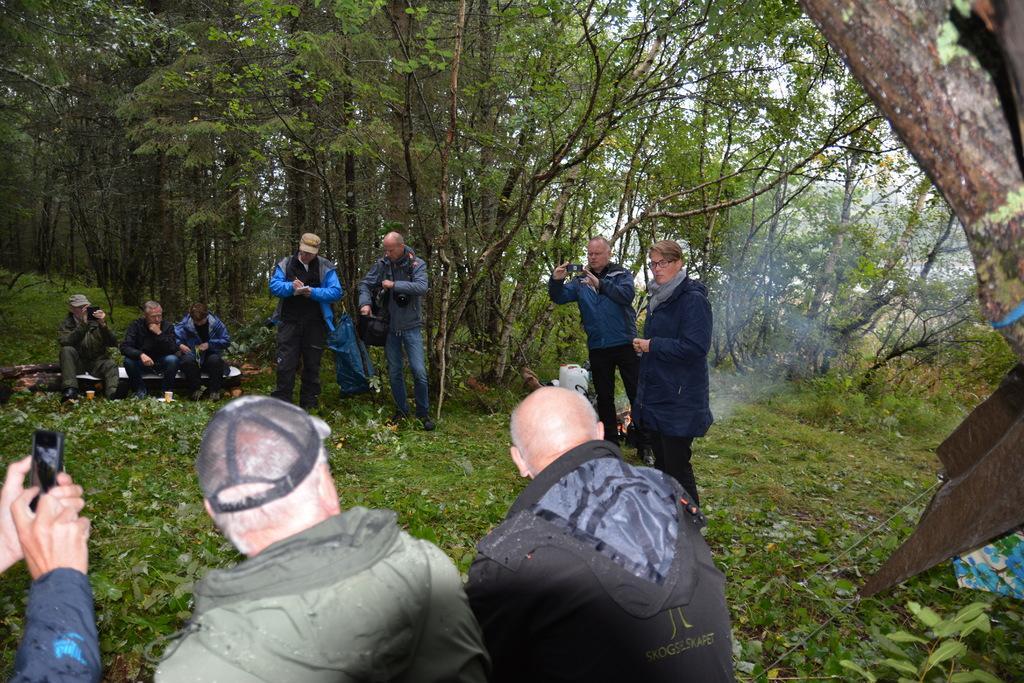In one or two sentences, can you explain what this image depicts? In this image we can see people standing and some of them are sitting. They are holding mobiles in their hands. In the background there are trees. At the bottom there is grass. 